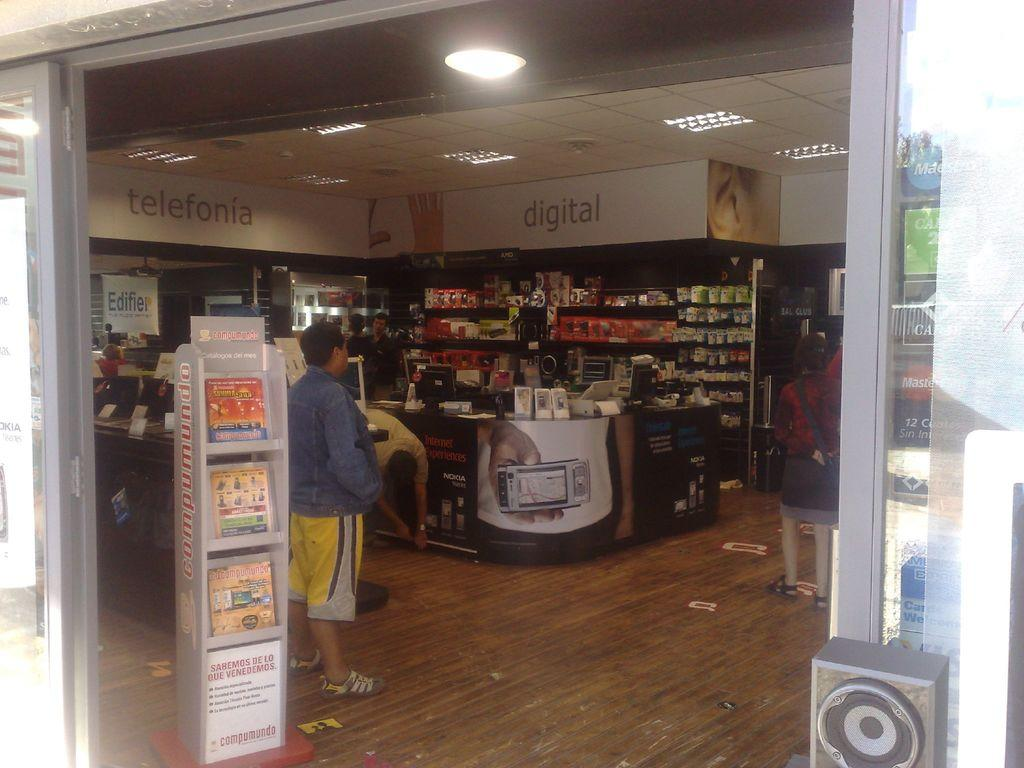<image>
Write a terse but informative summary of the picture. the inside of a store with displays of Digital and Telefonia 